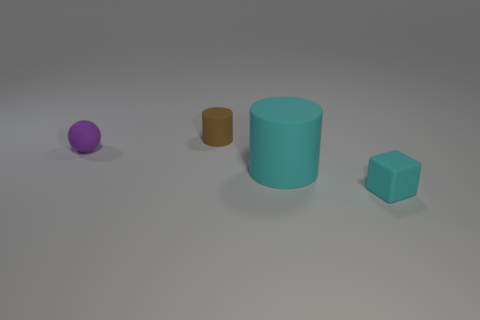What material is the thing behind the object that is left of the small brown rubber thing made of?
Provide a succinct answer. Rubber. How many other objects are the same material as the tiny sphere?
Offer a terse response. 3. There is a ball that is the same size as the rubber cube; what is it made of?
Provide a short and direct response. Rubber. Are there more big cyan rubber cylinders that are to the left of the purple rubber object than balls that are behind the brown thing?
Provide a succinct answer. No. Are there any brown shiny objects of the same shape as the purple thing?
Make the answer very short. No. The purple thing that is the same size as the brown matte thing is what shape?
Keep it short and to the point. Sphere. What shape is the matte thing that is on the right side of the big cyan matte cylinder?
Provide a short and direct response. Cube. Are there fewer brown objects that are to the left of the brown object than purple objects to the right of the tiny purple rubber sphere?
Your answer should be very brief. No. There is a rubber ball; does it have the same size as the thing behind the purple rubber sphere?
Offer a very short reply. Yes. What number of objects have the same size as the rubber block?
Your response must be concise. 2. 